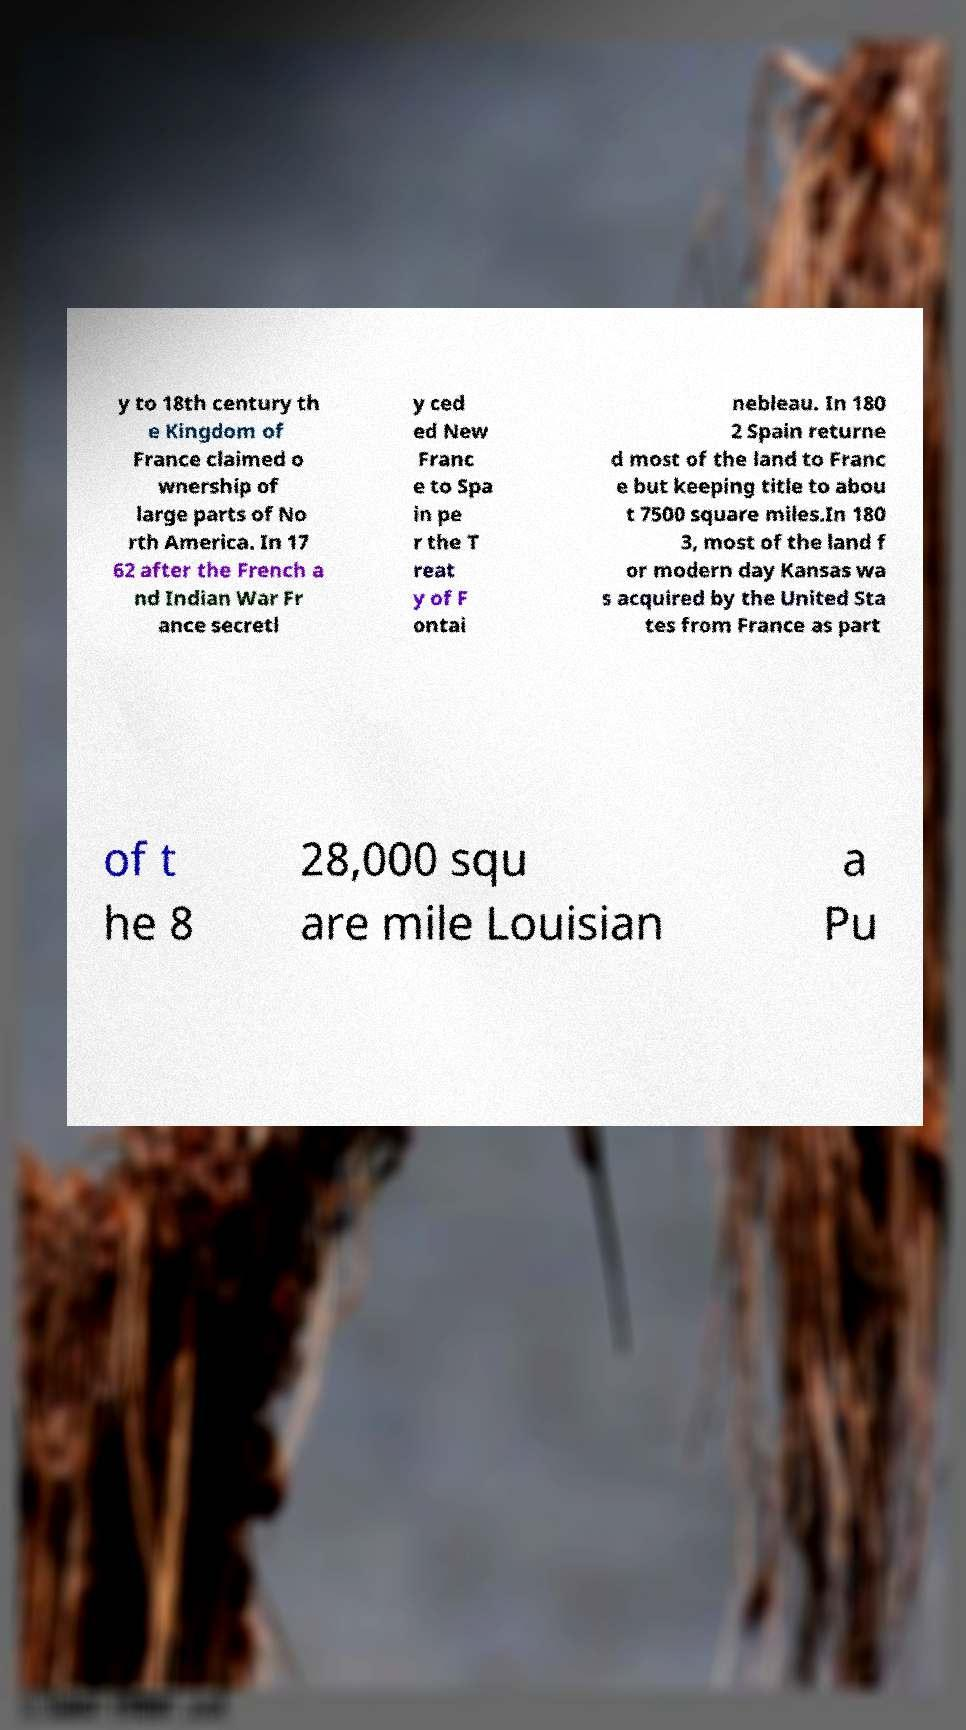What messages or text are displayed in this image? I need them in a readable, typed format. y to 18th century th e Kingdom of France claimed o wnership of large parts of No rth America. In 17 62 after the French a nd Indian War Fr ance secretl y ced ed New Franc e to Spa in pe r the T reat y of F ontai nebleau. In 180 2 Spain returne d most of the land to Franc e but keeping title to abou t 7500 square miles.In 180 3, most of the land f or modern day Kansas wa s acquired by the United Sta tes from France as part of t he 8 28,000 squ are mile Louisian a Pu 